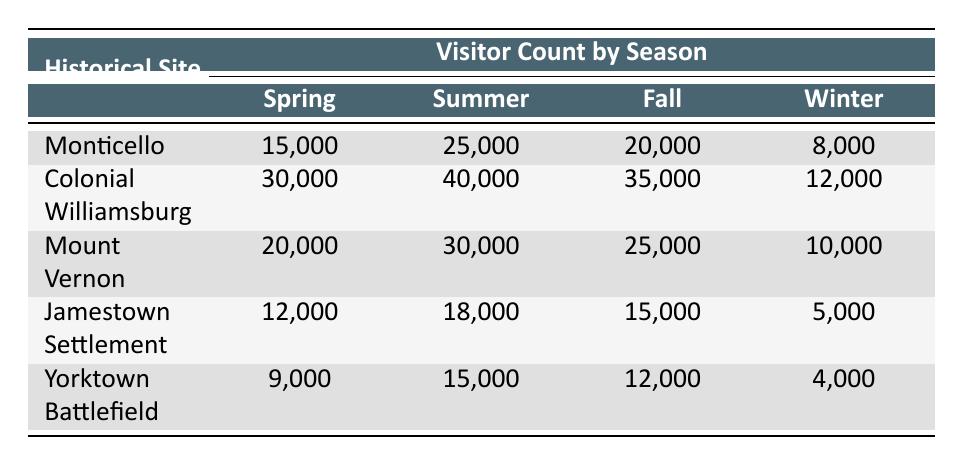What is the visitor count for Monticello in the summer? According to the table, the visitor count for Monticello in the summer season is found directly in the Summer column under the Monticello row, which states 25,000.
Answer: 25,000 Which historical site had the highest visitor count in the spring? By examining the Spring column for each site, Colonial Williamsburg shows the highest visitor count of 30,000, compared to Monticello's 15,000, Mount Vernon's 20,000, Jamestown Settlement's 12,000, and Yorktown Battlefield's 9,000.
Answer: Colonial Williamsburg What is the total number of visitors to Mount Vernon across all seasons? To find the total, add the visitor counts for each season for Mount Vernon: 20,000 (Spring) + 30,000 (Summer) + 25,000 (Fall) + 10,000 (Winter) = 85,000.
Answer: 85,000 Is the visitor count for Yorktown Battlefield equal to 10,000 in the winter? By looking at the Winter column under the Yorktown Battlefield row, the visitor count is 4,000, not 10,000, which confirms the statement is false.
Answer: No What is the difference in visitor counts between Colonial Williamsburg in summer and winter? To find the difference, subtract the winter visitor count (12,000) from summer visitor count (40,000): 40,000 - 12,000 = 28,000. This indicates that there are 28,000 more visitors in the summer compared to winter at Colonial Williamsburg.
Answer: 28,000 Which season has the lowest visitor count for Jamestown Settlement? Checking the visitor counts across all seasons, the Winter season shows the lowest number of visitors at 5,000, compared to 12,000 (Spring), 18,000 (Summer), and 15,000 (Fall).
Answer: Winter What is the average visitor count for all sites in the fall? First, sum the visitor counts for fall: Monticello (20,000) + Colonial Williamsburg (35,000) + Mount Vernon (25,000) + Jamestown Settlement (15,000) + Yorktown Battlefield (12,000) = 107,000. There are 5 sites, so the average is 107,000 / 5 = 21,400.
Answer: 21,400 Is Mount Vernon the only site with more than 20,000 visitors in the spring? Comparing the Spring visitor counts: Monticello (15,000), Colonial Williamsburg (30,000), Mount Vernon (20,000), Jamestown Settlement (12,000), and Yorktown Battlefield (9,000), we see that both Colonial Williamsburg (30,000) and Mount Vernon (20,000) exceed 20,000, making the statement false.
Answer: No 